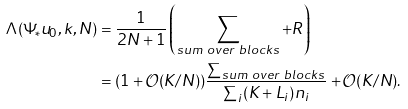Convert formula to latex. <formula><loc_0><loc_0><loc_500><loc_500>\Lambda ( \Psi _ { * } u _ { 0 } , k , N ) & = \frac { 1 } { 2 N + 1 } \left ( \sum _ { s u m \ o v e r \ b l o c k s } + R \right ) \\ & = ( 1 + \mathcal { O } ( K / N ) ) \frac { \sum _ { s u m \ o v e r \ b l o c k s } } { \sum _ { i } ( K + L _ { i } ) n _ { i } } + \mathcal { O } ( K / N ) .</formula> 